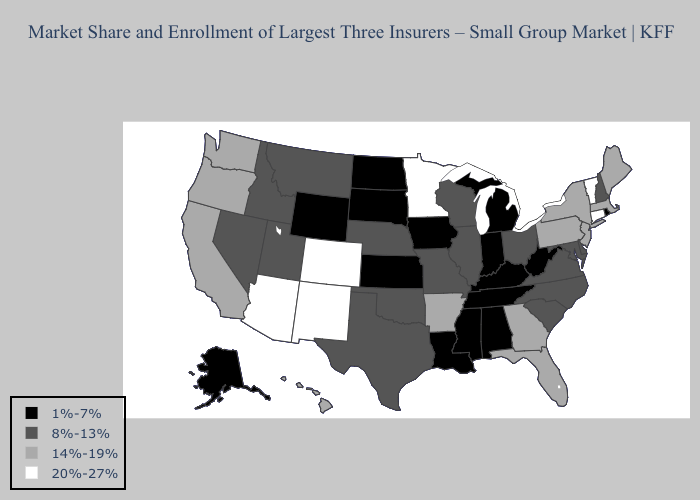What is the value of Alabama?
Give a very brief answer. 1%-7%. Does Idaho have the highest value in the USA?
Write a very short answer. No. Does Rhode Island have a lower value than Kansas?
Quick response, please. No. Does Kansas have the lowest value in the USA?
Give a very brief answer. Yes. Does the first symbol in the legend represent the smallest category?
Keep it brief. Yes. Does Wyoming have the highest value in the West?
Answer briefly. No. What is the lowest value in states that border New Hampshire?
Quick response, please. 14%-19%. Which states have the lowest value in the USA?
Write a very short answer. Alabama, Alaska, Indiana, Iowa, Kansas, Kentucky, Louisiana, Michigan, Mississippi, North Dakota, Rhode Island, South Dakota, Tennessee, West Virginia, Wyoming. What is the value of Alaska?
Give a very brief answer. 1%-7%. Is the legend a continuous bar?
Short answer required. No. Name the states that have a value in the range 14%-19%?
Short answer required. Arkansas, California, Florida, Georgia, Hawaii, Maine, Massachusetts, New Jersey, New York, Oregon, Pennsylvania, Washington. Name the states that have a value in the range 14%-19%?
Concise answer only. Arkansas, California, Florida, Georgia, Hawaii, Maine, Massachusetts, New Jersey, New York, Oregon, Pennsylvania, Washington. What is the lowest value in states that border Montana?
Answer briefly. 1%-7%. Which states have the lowest value in the MidWest?
Short answer required. Indiana, Iowa, Kansas, Michigan, North Dakota, South Dakota. What is the highest value in the Northeast ?
Short answer required. 20%-27%. 